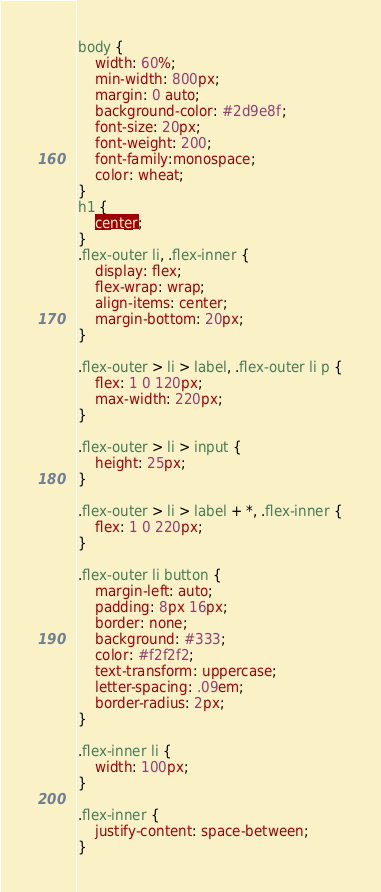<code> <loc_0><loc_0><loc_500><loc_500><_CSS_>body {
    width: 60%;
    min-width: 800px;
    margin: 0 auto;
    background-color: #2d9e8f;
    font-size: 20px;
    font-weight: 200;
    font-family:monospace;
    color: wheat;
}
h1 {
    center;
}
.flex-outer li, .flex-inner {
    display: flex;
    flex-wrap: wrap;
    align-items: center;
    margin-bottom: 20px;
}

.flex-outer > li > label, .flex-outer li p {
    flex: 1 0 120px;
    max-width: 220px;
}

.flex-outer > li > input {
    height: 25px;
}

.flex-outer > li > label + *, .flex-inner {
    flex: 1 0 220px;
}

.flex-outer li button {
    margin-left: auto;
    padding: 8px 16px;
    border: none;
    background: #333;
    color: #f2f2f2;
    text-transform: uppercase;
    letter-spacing: .09em;
    border-radius: 2px;
}

.flex-inner li {
    width: 100px;
}

.flex-inner {
    justify-content: space-between;
}</code> 